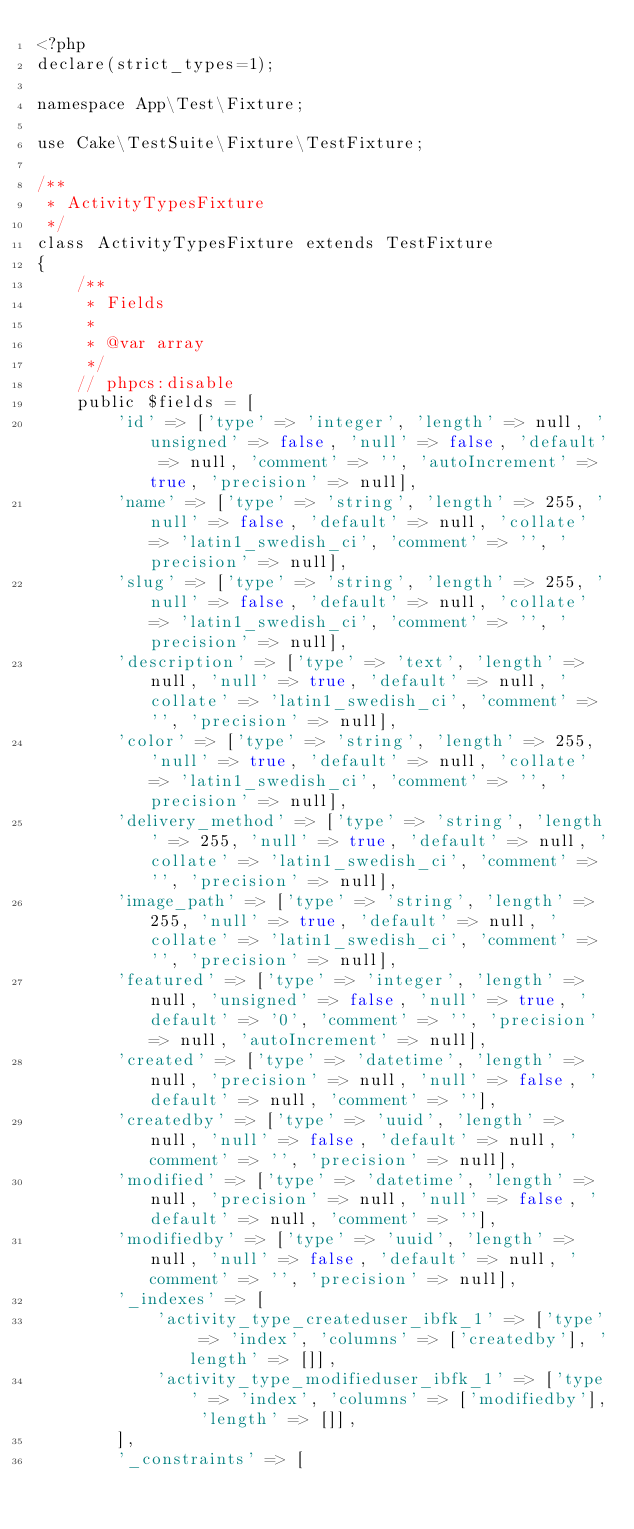Convert code to text. <code><loc_0><loc_0><loc_500><loc_500><_PHP_><?php
declare(strict_types=1);

namespace App\Test\Fixture;

use Cake\TestSuite\Fixture\TestFixture;

/**
 * ActivityTypesFixture
 */
class ActivityTypesFixture extends TestFixture
{
    /**
     * Fields
     *
     * @var array
     */
    // phpcs:disable
    public $fields = [
        'id' => ['type' => 'integer', 'length' => null, 'unsigned' => false, 'null' => false, 'default' => null, 'comment' => '', 'autoIncrement' => true, 'precision' => null],
        'name' => ['type' => 'string', 'length' => 255, 'null' => false, 'default' => null, 'collate' => 'latin1_swedish_ci', 'comment' => '', 'precision' => null],
        'slug' => ['type' => 'string', 'length' => 255, 'null' => false, 'default' => null, 'collate' => 'latin1_swedish_ci', 'comment' => '', 'precision' => null],
        'description' => ['type' => 'text', 'length' => null, 'null' => true, 'default' => null, 'collate' => 'latin1_swedish_ci', 'comment' => '', 'precision' => null],
        'color' => ['type' => 'string', 'length' => 255, 'null' => true, 'default' => null, 'collate' => 'latin1_swedish_ci', 'comment' => '', 'precision' => null],
        'delivery_method' => ['type' => 'string', 'length' => 255, 'null' => true, 'default' => null, 'collate' => 'latin1_swedish_ci', 'comment' => '', 'precision' => null],
        'image_path' => ['type' => 'string', 'length' => 255, 'null' => true, 'default' => null, 'collate' => 'latin1_swedish_ci', 'comment' => '', 'precision' => null],
        'featured' => ['type' => 'integer', 'length' => null, 'unsigned' => false, 'null' => true, 'default' => '0', 'comment' => '', 'precision' => null, 'autoIncrement' => null],
        'created' => ['type' => 'datetime', 'length' => null, 'precision' => null, 'null' => false, 'default' => null, 'comment' => ''],
        'createdby' => ['type' => 'uuid', 'length' => null, 'null' => false, 'default' => null, 'comment' => '', 'precision' => null],
        'modified' => ['type' => 'datetime', 'length' => null, 'precision' => null, 'null' => false, 'default' => null, 'comment' => ''],
        'modifiedby' => ['type' => 'uuid', 'length' => null, 'null' => false, 'default' => null, 'comment' => '', 'precision' => null],
        '_indexes' => [
            'activity_type_createduser_ibfk_1' => ['type' => 'index', 'columns' => ['createdby'], 'length' => []],
            'activity_type_modifieduser_ibfk_1' => ['type' => 'index', 'columns' => ['modifiedby'], 'length' => []],
        ],
        '_constraints' => [</code> 